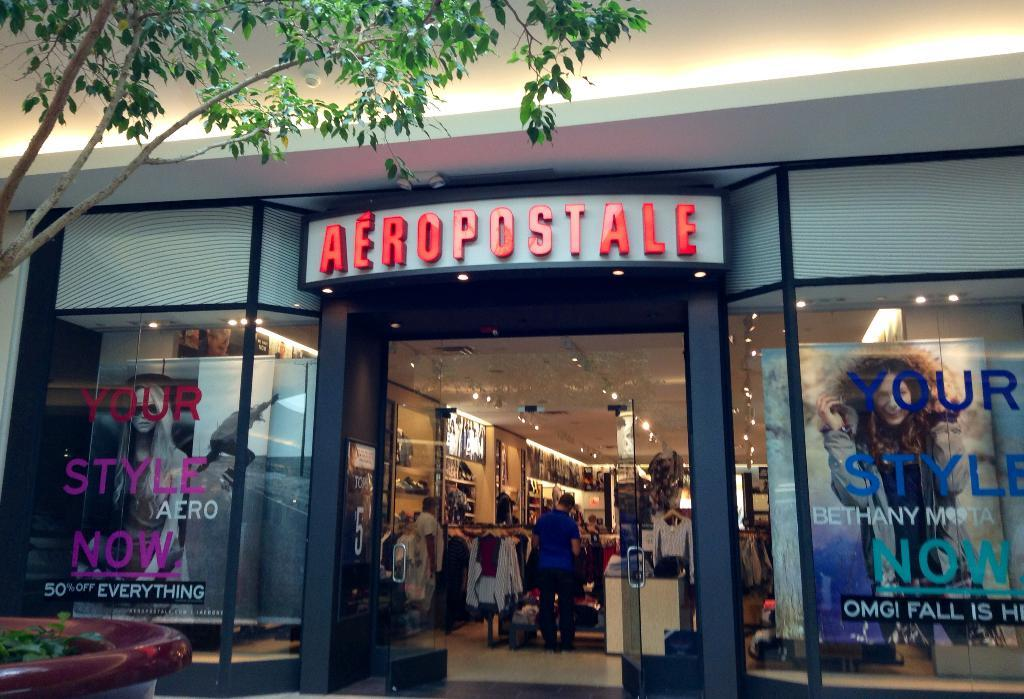What type of establishment is depicted in the image? There is a store in the image. Can you describe the presence of a person in the image? There is a person in the store. What can be seen in the middle of the image? There are lights in the middle of the image. What natural element is visible at the top of the image? There is a tree at the top of the image. What type of machine is being operated by the laborer in the image? There is no laborer or machine present in the image. What color is the sweater worn by the person in the image? The provided facts do not mention the color of the person's clothing, so we cannot determine the color of the sweater. 